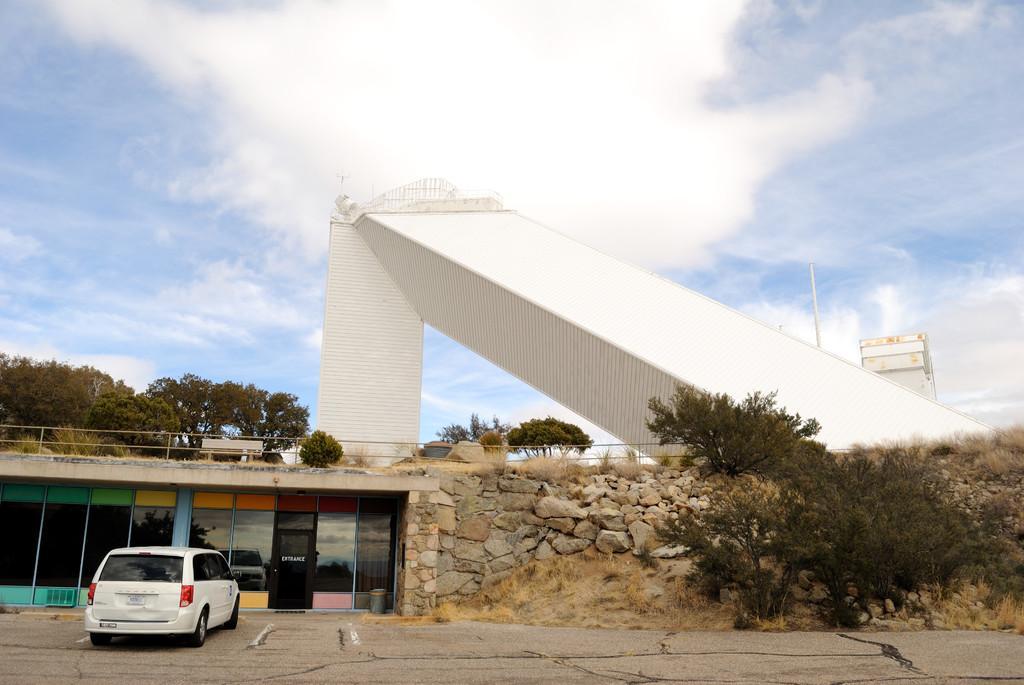How would you summarize this image in a sentence or two? In this image we can see the building, rock wall, railing, bench and also the vehicle parked on the path. We can also see the concrete structure. Image also consists of trees. In the background we can see the sky with the clouds. 